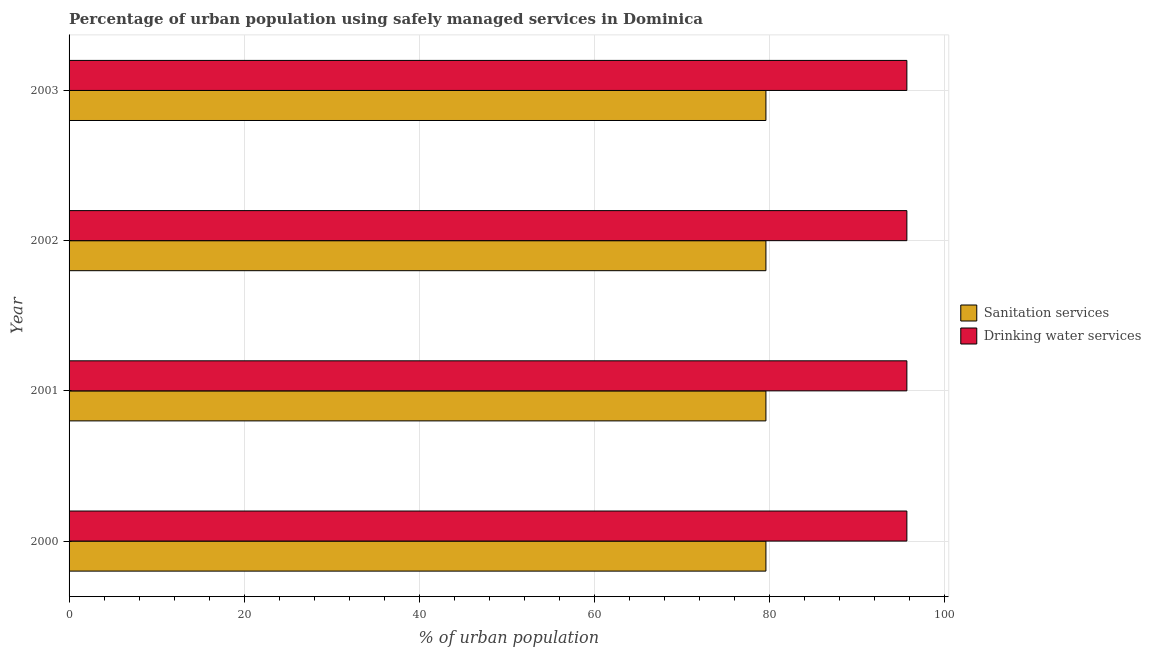Are the number of bars per tick equal to the number of legend labels?
Offer a very short reply. Yes. Are the number of bars on each tick of the Y-axis equal?
Your answer should be compact. Yes. How many bars are there on the 2nd tick from the bottom?
Offer a very short reply. 2. What is the label of the 2nd group of bars from the top?
Offer a terse response. 2002. What is the percentage of urban population who used sanitation services in 2003?
Give a very brief answer. 79.6. Across all years, what is the maximum percentage of urban population who used sanitation services?
Provide a succinct answer. 79.6. Across all years, what is the minimum percentage of urban population who used drinking water services?
Your response must be concise. 95.7. In which year was the percentage of urban population who used drinking water services maximum?
Your answer should be very brief. 2000. What is the total percentage of urban population who used drinking water services in the graph?
Make the answer very short. 382.8. What is the difference between the percentage of urban population who used sanitation services in 2001 and that in 2003?
Your answer should be very brief. 0. What is the difference between the percentage of urban population who used sanitation services in 2003 and the percentage of urban population who used drinking water services in 2000?
Provide a succinct answer. -16.1. What is the average percentage of urban population who used drinking water services per year?
Provide a succinct answer. 95.7. In the year 2000, what is the difference between the percentage of urban population who used sanitation services and percentage of urban population who used drinking water services?
Your answer should be compact. -16.1. What is the ratio of the percentage of urban population who used drinking water services in 2001 to that in 2002?
Offer a very short reply. 1. Is the percentage of urban population who used sanitation services in 2000 less than that in 2003?
Ensure brevity in your answer.  No. What is the difference between the highest and the second highest percentage of urban population who used drinking water services?
Keep it short and to the point. 0. What is the difference between the highest and the lowest percentage of urban population who used sanitation services?
Your answer should be compact. 0. Is the sum of the percentage of urban population who used sanitation services in 2001 and 2003 greater than the maximum percentage of urban population who used drinking water services across all years?
Keep it short and to the point. Yes. What does the 2nd bar from the top in 2002 represents?
Provide a short and direct response. Sanitation services. What does the 1st bar from the bottom in 2001 represents?
Give a very brief answer. Sanitation services. How many bars are there?
Offer a very short reply. 8. Are the values on the major ticks of X-axis written in scientific E-notation?
Provide a short and direct response. No. What is the title of the graph?
Your response must be concise. Percentage of urban population using safely managed services in Dominica. What is the label or title of the X-axis?
Offer a terse response. % of urban population. What is the label or title of the Y-axis?
Your response must be concise. Year. What is the % of urban population of Sanitation services in 2000?
Provide a succinct answer. 79.6. What is the % of urban population of Drinking water services in 2000?
Keep it short and to the point. 95.7. What is the % of urban population of Sanitation services in 2001?
Make the answer very short. 79.6. What is the % of urban population of Drinking water services in 2001?
Your answer should be very brief. 95.7. What is the % of urban population of Sanitation services in 2002?
Offer a terse response. 79.6. What is the % of urban population in Drinking water services in 2002?
Make the answer very short. 95.7. What is the % of urban population of Sanitation services in 2003?
Offer a very short reply. 79.6. What is the % of urban population of Drinking water services in 2003?
Give a very brief answer. 95.7. Across all years, what is the maximum % of urban population of Sanitation services?
Your answer should be compact. 79.6. Across all years, what is the maximum % of urban population in Drinking water services?
Make the answer very short. 95.7. Across all years, what is the minimum % of urban population of Sanitation services?
Make the answer very short. 79.6. Across all years, what is the minimum % of urban population of Drinking water services?
Make the answer very short. 95.7. What is the total % of urban population in Sanitation services in the graph?
Give a very brief answer. 318.4. What is the total % of urban population of Drinking water services in the graph?
Give a very brief answer. 382.8. What is the difference between the % of urban population of Drinking water services in 2000 and that in 2001?
Offer a very short reply. 0. What is the difference between the % of urban population in Sanitation services in 2000 and that in 2002?
Your response must be concise. 0. What is the difference between the % of urban population in Sanitation services in 2001 and that in 2003?
Your response must be concise. 0. What is the difference between the % of urban population of Sanitation services in 2002 and that in 2003?
Your answer should be compact. 0. What is the difference between the % of urban population in Sanitation services in 2000 and the % of urban population in Drinking water services in 2001?
Your response must be concise. -16.1. What is the difference between the % of urban population in Sanitation services in 2000 and the % of urban population in Drinking water services in 2002?
Your answer should be compact. -16.1. What is the difference between the % of urban population of Sanitation services in 2000 and the % of urban population of Drinking water services in 2003?
Ensure brevity in your answer.  -16.1. What is the difference between the % of urban population of Sanitation services in 2001 and the % of urban population of Drinking water services in 2002?
Your answer should be compact. -16.1. What is the difference between the % of urban population of Sanitation services in 2001 and the % of urban population of Drinking water services in 2003?
Make the answer very short. -16.1. What is the difference between the % of urban population in Sanitation services in 2002 and the % of urban population in Drinking water services in 2003?
Provide a succinct answer. -16.1. What is the average % of urban population of Sanitation services per year?
Provide a succinct answer. 79.6. What is the average % of urban population in Drinking water services per year?
Provide a short and direct response. 95.7. In the year 2000, what is the difference between the % of urban population of Sanitation services and % of urban population of Drinking water services?
Make the answer very short. -16.1. In the year 2001, what is the difference between the % of urban population of Sanitation services and % of urban population of Drinking water services?
Give a very brief answer. -16.1. In the year 2002, what is the difference between the % of urban population in Sanitation services and % of urban population in Drinking water services?
Make the answer very short. -16.1. In the year 2003, what is the difference between the % of urban population in Sanitation services and % of urban population in Drinking water services?
Make the answer very short. -16.1. What is the ratio of the % of urban population of Drinking water services in 2000 to that in 2001?
Offer a terse response. 1. What is the ratio of the % of urban population in Sanitation services in 2000 to that in 2002?
Keep it short and to the point. 1. What is the ratio of the % of urban population in Drinking water services in 2000 to that in 2002?
Your response must be concise. 1. What is the ratio of the % of urban population of Sanitation services in 2000 to that in 2003?
Ensure brevity in your answer.  1. What is the ratio of the % of urban population of Sanitation services in 2001 to that in 2002?
Offer a very short reply. 1. What is the ratio of the % of urban population in Drinking water services in 2001 to that in 2002?
Provide a short and direct response. 1. What is the ratio of the % of urban population of Sanitation services in 2001 to that in 2003?
Make the answer very short. 1. What is the ratio of the % of urban population in Drinking water services in 2001 to that in 2003?
Offer a very short reply. 1. What is the ratio of the % of urban population of Sanitation services in 2002 to that in 2003?
Provide a succinct answer. 1. What is the difference between the highest and the second highest % of urban population in Sanitation services?
Offer a terse response. 0. What is the difference between the highest and the second highest % of urban population in Drinking water services?
Keep it short and to the point. 0. What is the difference between the highest and the lowest % of urban population of Sanitation services?
Your answer should be compact. 0. 